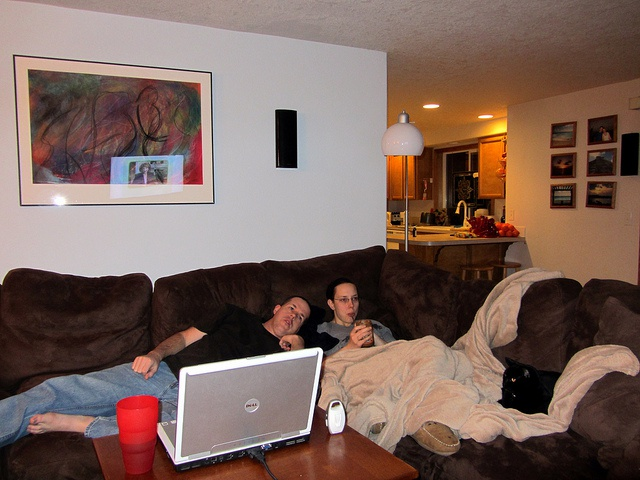Describe the objects in this image and their specific colors. I can see couch in darkgray, black, and gray tones, people in darkgray, black, gray, and brown tones, laptop in darkgray, gray, white, and black tones, people in darkgray, gray, black, brown, and maroon tones, and cat in darkgray, black, gray, darkgreen, and tan tones in this image. 